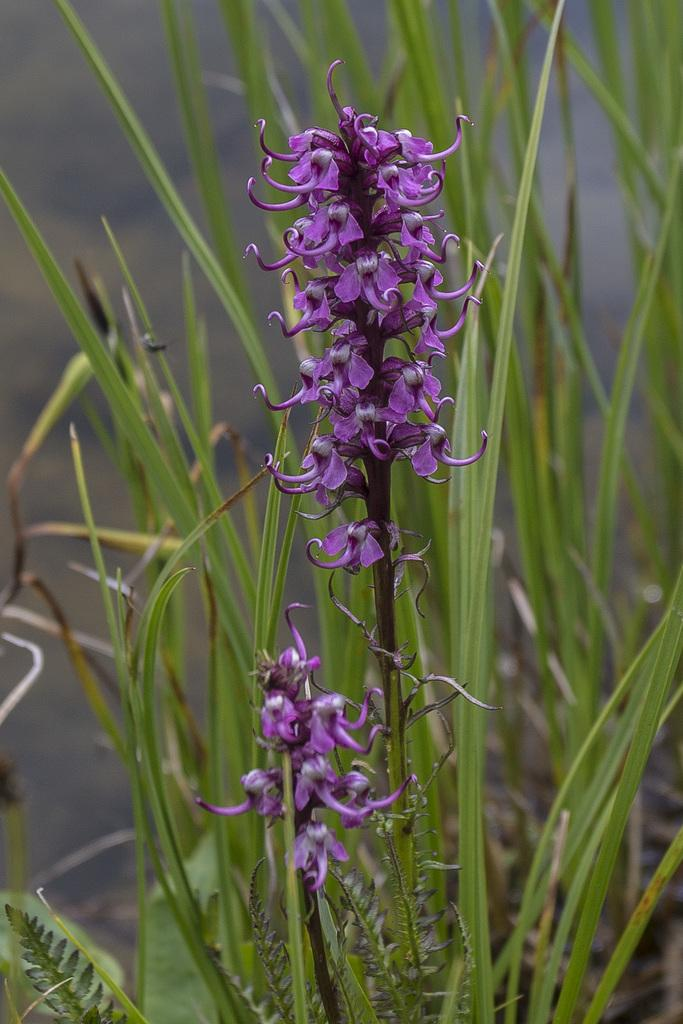What is the main subject of the image? There is a group of flowers on the stem of a plant in the image. Can you describe the plants in the background? There are plants visible in the background of the image. What type of umbrella is being used to protect the flowers from the rain in the image? There is no umbrella present in the image, and the flowers are not being protected from the rain. 